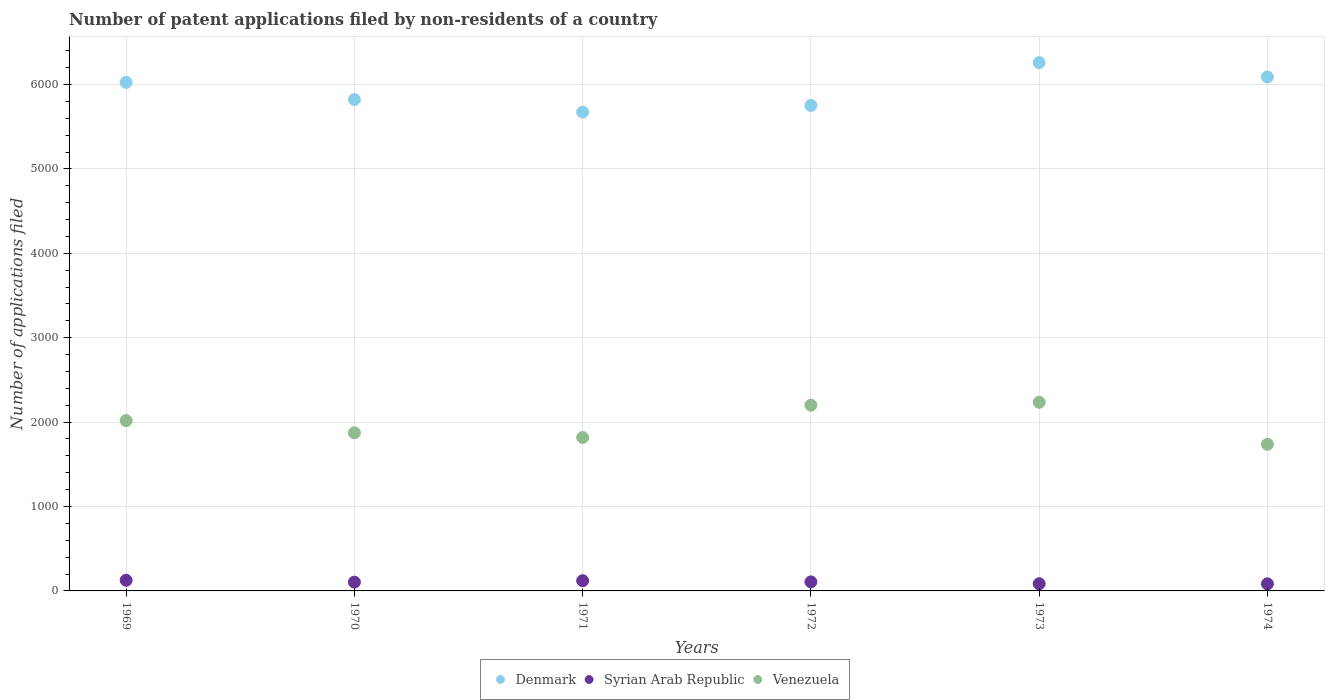How many different coloured dotlines are there?
Make the answer very short. 3. Is the number of dotlines equal to the number of legend labels?
Ensure brevity in your answer.  Yes. What is the number of applications filed in Denmark in 1973?
Your answer should be compact. 6259. Across all years, what is the maximum number of applications filed in Denmark?
Your answer should be compact. 6259. Across all years, what is the minimum number of applications filed in Syrian Arab Republic?
Provide a short and direct response. 84. In which year was the number of applications filed in Venezuela minimum?
Offer a terse response. 1974. What is the total number of applications filed in Syrian Arab Republic in the graph?
Your answer should be compact. 627. What is the difference between the number of applications filed in Venezuela in 1970 and that in 1971?
Your response must be concise. 55. What is the difference between the number of applications filed in Denmark in 1973 and the number of applications filed in Syrian Arab Republic in 1972?
Give a very brief answer. 6152. What is the average number of applications filed in Venezuela per year?
Give a very brief answer. 1980.33. In the year 1974, what is the difference between the number of applications filed in Syrian Arab Republic and number of applications filed in Venezuela?
Make the answer very short. -1653. In how many years, is the number of applications filed in Denmark greater than 1600?
Your answer should be compact. 6. What is the ratio of the number of applications filed in Denmark in 1969 to that in 1973?
Offer a terse response. 0.96. Is the number of applications filed in Denmark in 1969 less than that in 1970?
Make the answer very short. No. Is the difference between the number of applications filed in Syrian Arab Republic in 1972 and 1973 greater than the difference between the number of applications filed in Venezuela in 1972 and 1973?
Provide a succinct answer. Yes. What is the difference between the highest and the second highest number of applications filed in Denmark?
Offer a very short reply. 170. What is the difference between the highest and the lowest number of applications filed in Venezuela?
Give a very brief answer. 498. Is the sum of the number of applications filed in Syrian Arab Republic in 1971 and 1972 greater than the maximum number of applications filed in Denmark across all years?
Offer a terse response. No. Is it the case that in every year, the sum of the number of applications filed in Denmark and number of applications filed in Syrian Arab Republic  is greater than the number of applications filed in Venezuela?
Your answer should be compact. Yes. Does the number of applications filed in Denmark monotonically increase over the years?
Make the answer very short. No. Is the number of applications filed in Denmark strictly greater than the number of applications filed in Venezuela over the years?
Ensure brevity in your answer.  Yes. How many legend labels are there?
Keep it short and to the point. 3. What is the title of the graph?
Make the answer very short. Number of patent applications filed by non-residents of a country. What is the label or title of the X-axis?
Ensure brevity in your answer.  Years. What is the label or title of the Y-axis?
Offer a terse response. Number of applications filed. What is the Number of applications filed in Denmark in 1969?
Your response must be concise. 6025. What is the Number of applications filed in Syrian Arab Republic in 1969?
Offer a terse response. 126. What is the Number of applications filed in Venezuela in 1969?
Your response must be concise. 2018. What is the Number of applications filed in Denmark in 1970?
Your answer should be very brief. 5822. What is the Number of applications filed in Syrian Arab Republic in 1970?
Make the answer very short. 104. What is the Number of applications filed in Venezuela in 1970?
Your answer should be compact. 1873. What is the Number of applications filed in Denmark in 1971?
Ensure brevity in your answer.  5673. What is the Number of applications filed of Syrian Arab Republic in 1971?
Offer a very short reply. 121. What is the Number of applications filed of Venezuela in 1971?
Provide a succinct answer. 1818. What is the Number of applications filed of Denmark in 1972?
Keep it short and to the point. 5752. What is the Number of applications filed of Syrian Arab Republic in 1972?
Ensure brevity in your answer.  107. What is the Number of applications filed of Venezuela in 1972?
Your answer should be compact. 2201. What is the Number of applications filed of Denmark in 1973?
Your answer should be very brief. 6259. What is the Number of applications filed of Syrian Arab Republic in 1973?
Provide a succinct answer. 85. What is the Number of applications filed in Venezuela in 1973?
Offer a terse response. 2235. What is the Number of applications filed in Denmark in 1974?
Make the answer very short. 6089. What is the Number of applications filed of Syrian Arab Republic in 1974?
Your answer should be compact. 84. What is the Number of applications filed in Venezuela in 1974?
Offer a terse response. 1737. Across all years, what is the maximum Number of applications filed in Denmark?
Provide a succinct answer. 6259. Across all years, what is the maximum Number of applications filed of Syrian Arab Republic?
Offer a very short reply. 126. Across all years, what is the maximum Number of applications filed in Venezuela?
Offer a terse response. 2235. Across all years, what is the minimum Number of applications filed of Denmark?
Your answer should be compact. 5673. Across all years, what is the minimum Number of applications filed of Venezuela?
Offer a very short reply. 1737. What is the total Number of applications filed of Denmark in the graph?
Ensure brevity in your answer.  3.56e+04. What is the total Number of applications filed in Syrian Arab Republic in the graph?
Your answer should be compact. 627. What is the total Number of applications filed of Venezuela in the graph?
Give a very brief answer. 1.19e+04. What is the difference between the Number of applications filed of Denmark in 1969 and that in 1970?
Your answer should be compact. 203. What is the difference between the Number of applications filed of Venezuela in 1969 and that in 1970?
Provide a succinct answer. 145. What is the difference between the Number of applications filed in Denmark in 1969 and that in 1971?
Offer a very short reply. 352. What is the difference between the Number of applications filed in Venezuela in 1969 and that in 1971?
Give a very brief answer. 200. What is the difference between the Number of applications filed in Denmark in 1969 and that in 1972?
Ensure brevity in your answer.  273. What is the difference between the Number of applications filed in Venezuela in 1969 and that in 1972?
Make the answer very short. -183. What is the difference between the Number of applications filed of Denmark in 1969 and that in 1973?
Ensure brevity in your answer.  -234. What is the difference between the Number of applications filed in Venezuela in 1969 and that in 1973?
Provide a succinct answer. -217. What is the difference between the Number of applications filed of Denmark in 1969 and that in 1974?
Your answer should be very brief. -64. What is the difference between the Number of applications filed of Syrian Arab Republic in 1969 and that in 1974?
Keep it short and to the point. 42. What is the difference between the Number of applications filed in Venezuela in 1969 and that in 1974?
Your answer should be very brief. 281. What is the difference between the Number of applications filed of Denmark in 1970 and that in 1971?
Offer a terse response. 149. What is the difference between the Number of applications filed of Syrian Arab Republic in 1970 and that in 1972?
Ensure brevity in your answer.  -3. What is the difference between the Number of applications filed of Venezuela in 1970 and that in 1972?
Offer a terse response. -328. What is the difference between the Number of applications filed in Denmark in 1970 and that in 1973?
Give a very brief answer. -437. What is the difference between the Number of applications filed of Venezuela in 1970 and that in 1973?
Offer a very short reply. -362. What is the difference between the Number of applications filed of Denmark in 1970 and that in 1974?
Provide a short and direct response. -267. What is the difference between the Number of applications filed of Venezuela in 1970 and that in 1974?
Offer a very short reply. 136. What is the difference between the Number of applications filed in Denmark in 1971 and that in 1972?
Provide a short and direct response. -79. What is the difference between the Number of applications filed of Venezuela in 1971 and that in 1972?
Offer a terse response. -383. What is the difference between the Number of applications filed in Denmark in 1971 and that in 1973?
Offer a very short reply. -586. What is the difference between the Number of applications filed of Venezuela in 1971 and that in 1973?
Give a very brief answer. -417. What is the difference between the Number of applications filed in Denmark in 1971 and that in 1974?
Offer a terse response. -416. What is the difference between the Number of applications filed of Syrian Arab Republic in 1971 and that in 1974?
Your answer should be compact. 37. What is the difference between the Number of applications filed of Denmark in 1972 and that in 1973?
Your response must be concise. -507. What is the difference between the Number of applications filed in Venezuela in 1972 and that in 1973?
Make the answer very short. -34. What is the difference between the Number of applications filed in Denmark in 1972 and that in 1974?
Make the answer very short. -337. What is the difference between the Number of applications filed in Syrian Arab Republic in 1972 and that in 1974?
Offer a terse response. 23. What is the difference between the Number of applications filed of Venezuela in 1972 and that in 1974?
Ensure brevity in your answer.  464. What is the difference between the Number of applications filed in Denmark in 1973 and that in 1974?
Your answer should be very brief. 170. What is the difference between the Number of applications filed of Venezuela in 1973 and that in 1974?
Offer a terse response. 498. What is the difference between the Number of applications filed in Denmark in 1969 and the Number of applications filed in Syrian Arab Republic in 1970?
Ensure brevity in your answer.  5921. What is the difference between the Number of applications filed of Denmark in 1969 and the Number of applications filed of Venezuela in 1970?
Your answer should be compact. 4152. What is the difference between the Number of applications filed of Syrian Arab Republic in 1969 and the Number of applications filed of Venezuela in 1970?
Offer a very short reply. -1747. What is the difference between the Number of applications filed in Denmark in 1969 and the Number of applications filed in Syrian Arab Republic in 1971?
Give a very brief answer. 5904. What is the difference between the Number of applications filed in Denmark in 1969 and the Number of applications filed in Venezuela in 1971?
Offer a very short reply. 4207. What is the difference between the Number of applications filed of Syrian Arab Republic in 1969 and the Number of applications filed of Venezuela in 1971?
Offer a terse response. -1692. What is the difference between the Number of applications filed in Denmark in 1969 and the Number of applications filed in Syrian Arab Republic in 1972?
Provide a short and direct response. 5918. What is the difference between the Number of applications filed in Denmark in 1969 and the Number of applications filed in Venezuela in 1972?
Provide a short and direct response. 3824. What is the difference between the Number of applications filed of Syrian Arab Republic in 1969 and the Number of applications filed of Venezuela in 1972?
Your response must be concise. -2075. What is the difference between the Number of applications filed of Denmark in 1969 and the Number of applications filed of Syrian Arab Republic in 1973?
Your response must be concise. 5940. What is the difference between the Number of applications filed in Denmark in 1969 and the Number of applications filed in Venezuela in 1973?
Offer a very short reply. 3790. What is the difference between the Number of applications filed of Syrian Arab Republic in 1969 and the Number of applications filed of Venezuela in 1973?
Offer a terse response. -2109. What is the difference between the Number of applications filed in Denmark in 1969 and the Number of applications filed in Syrian Arab Republic in 1974?
Make the answer very short. 5941. What is the difference between the Number of applications filed of Denmark in 1969 and the Number of applications filed of Venezuela in 1974?
Provide a short and direct response. 4288. What is the difference between the Number of applications filed of Syrian Arab Republic in 1969 and the Number of applications filed of Venezuela in 1974?
Make the answer very short. -1611. What is the difference between the Number of applications filed in Denmark in 1970 and the Number of applications filed in Syrian Arab Republic in 1971?
Offer a terse response. 5701. What is the difference between the Number of applications filed of Denmark in 1970 and the Number of applications filed of Venezuela in 1971?
Give a very brief answer. 4004. What is the difference between the Number of applications filed of Syrian Arab Republic in 1970 and the Number of applications filed of Venezuela in 1971?
Give a very brief answer. -1714. What is the difference between the Number of applications filed in Denmark in 1970 and the Number of applications filed in Syrian Arab Republic in 1972?
Give a very brief answer. 5715. What is the difference between the Number of applications filed in Denmark in 1970 and the Number of applications filed in Venezuela in 1972?
Provide a short and direct response. 3621. What is the difference between the Number of applications filed in Syrian Arab Republic in 1970 and the Number of applications filed in Venezuela in 1972?
Provide a succinct answer. -2097. What is the difference between the Number of applications filed of Denmark in 1970 and the Number of applications filed of Syrian Arab Republic in 1973?
Offer a terse response. 5737. What is the difference between the Number of applications filed in Denmark in 1970 and the Number of applications filed in Venezuela in 1973?
Your answer should be very brief. 3587. What is the difference between the Number of applications filed of Syrian Arab Republic in 1970 and the Number of applications filed of Venezuela in 1973?
Make the answer very short. -2131. What is the difference between the Number of applications filed in Denmark in 1970 and the Number of applications filed in Syrian Arab Republic in 1974?
Provide a succinct answer. 5738. What is the difference between the Number of applications filed in Denmark in 1970 and the Number of applications filed in Venezuela in 1974?
Your answer should be compact. 4085. What is the difference between the Number of applications filed in Syrian Arab Republic in 1970 and the Number of applications filed in Venezuela in 1974?
Make the answer very short. -1633. What is the difference between the Number of applications filed in Denmark in 1971 and the Number of applications filed in Syrian Arab Republic in 1972?
Ensure brevity in your answer.  5566. What is the difference between the Number of applications filed of Denmark in 1971 and the Number of applications filed of Venezuela in 1972?
Offer a very short reply. 3472. What is the difference between the Number of applications filed in Syrian Arab Republic in 1971 and the Number of applications filed in Venezuela in 1972?
Provide a succinct answer. -2080. What is the difference between the Number of applications filed in Denmark in 1971 and the Number of applications filed in Syrian Arab Republic in 1973?
Your response must be concise. 5588. What is the difference between the Number of applications filed of Denmark in 1971 and the Number of applications filed of Venezuela in 1973?
Your answer should be very brief. 3438. What is the difference between the Number of applications filed of Syrian Arab Republic in 1971 and the Number of applications filed of Venezuela in 1973?
Ensure brevity in your answer.  -2114. What is the difference between the Number of applications filed in Denmark in 1971 and the Number of applications filed in Syrian Arab Republic in 1974?
Provide a succinct answer. 5589. What is the difference between the Number of applications filed of Denmark in 1971 and the Number of applications filed of Venezuela in 1974?
Offer a very short reply. 3936. What is the difference between the Number of applications filed of Syrian Arab Republic in 1971 and the Number of applications filed of Venezuela in 1974?
Keep it short and to the point. -1616. What is the difference between the Number of applications filed in Denmark in 1972 and the Number of applications filed in Syrian Arab Republic in 1973?
Offer a very short reply. 5667. What is the difference between the Number of applications filed of Denmark in 1972 and the Number of applications filed of Venezuela in 1973?
Provide a succinct answer. 3517. What is the difference between the Number of applications filed of Syrian Arab Republic in 1972 and the Number of applications filed of Venezuela in 1973?
Ensure brevity in your answer.  -2128. What is the difference between the Number of applications filed of Denmark in 1972 and the Number of applications filed of Syrian Arab Republic in 1974?
Provide a succinct answer. 5668. What is the difference between the Number of applications filed in Denmark in 1972 and the Number of applications filed in Venezuela in 1974?
Ensure brevity in your answer.  4015. What is the difference between the Number of applications filed of Syrian Arab Republic in 1972 and the Number of applications filed of Venezuela in 1974?
Give a very brief answer. -1630. What is the difference between the Number of applications filed of Denmark in 1973 and the Number of applications filed of Syrian Arab Republic in 1974?
Provide a short and direct response. 6175. What is the difference between the Number of applications filed of Denmark in 1973 and the Number of applications filed of Venezuela in 1974?
Make the answer very short. 4522. What is the difference between the Number of applications filed of Syrian Arab Republic in 1973 and the Number of applications filed of Venezuela in 1974?
Provide a short and direct response. -1652. What is the average Number of applications filed of Denmark per year?
Keep it short and to the point. 5936.67. What is the average Number of applications filed in Syrian Arab Republic per year?
Make the answer very short. 104.5. What is the average Number of applications filed in Venezuela per year?
Provide a short and direct response. 1980.33. In the year 1969, what is the difference between the Number of applications filed of Denmark and Number of applications filed of Syrian Arab Republic?
Offer a terse response. 5899. In the year 1969, what is the difference between the Number of applications filed in Denmark and Number of applications filed in Venezuela?
Give a very brief answer. 4007. In the year 1969, what is the difference between the Number of applications filed in Syrian Arab Republic and Number of applications filed in Venezuela?
Offer a terse response. -1892. In the year 1970, what is the difference between the Number of applications filed in Denmark and Number of applications filed in Syrian Arab Republic?
Give a very brief answer. 5718. In the year 1970, what is the difference between the Number of applications filed of Denmark and Number of applications filed of Venezuela?
Your response must be concise. 3949. In the year 1970, what is the difference between the Number of applications filed of Syrian Arab Republic and Number of applications filed of Venezuela?
Make the answer very short. -1769. In the year 1971, what is the difference between the Number of applications filed in Denmark and Number of applications filed in Syrian Arab Republic?
Keep it short and to the point. 5552. In the year 1971, what is the difference between the Number of applications filed in Denmark and Number of applications filed in Venezuela?
Keep it short and to the point. 3855. In the year 1971, what is the difference between the Number of applications filed in Syrian Arab Republic and Number of applications filed in Venezuela?
Ensure brevity in your answer.  -1697. In the year 1972, what is the difference between the Number of applications filed in Denmark and Number of applications filed in Syrian Arab Republic?
Make the answer very short. 5645. In the year 1972, what is the difference between the Number of applications filed in Denmark and Number of applications filed in Venezuela?
Provide a short and direct response. 3551. In the year 1972, what is the difference between the Number of applications filed of Syrian Arab Republic and Number of applications filed of Venezuela?
Your response must be concise. -2094. In the year 1973, what is the difference between the Number of applications filed of Denmark and Number of applications filed of Syrian Arab Republic?
Provide a succinct answer. 6174. In the year 1973, what is the difference between the Number of applications filed in Denmark and Number of applications filed in Venezuela?
Keep it short and to the point. 4024. In the year 1973, what is the difference between the Number of applications filed of Syrian Arab Republic and Number of applications filed of Venezuela?
Your answer should be compact. -2150. In the year 1974, what is the difference between the Number of applications filed of Denmark and Number of applications filed of Syrian Arab Republic?
Offer a terse response. 6005. In the year 1974, what is the difference between the Number of applications filed in Denmark and Number of applications filed in Venezuela?
Provide a short and direct response. 4352. In the year 1974, what is the difference between the Number of applications filed in Syrian Arab Republic and Number of applications filed in Venezuela?
Your response must be concise. -1653. What is the ratio of the Number of applications filed of Denmark in 1969 to that in 1970?
Keep it short and to the point. 1.03. What is the ratio of the Number of applications filed in Syrian Arab Republic in 1969 to that in 1970?
Offer a terse response. 1.21. What is the ratio of the Number of applications filed of Venezuela in 1969 to that in 1970?
Your answer should be compact. 1.08. What is the ratio of the Number of applications filed in Denmark in 1969 to that in 1971?
Your response must be concise. 1.06. What is the ratio of the Number of applications filed of Syrian Arab Republic in 1969 to that in 1971?
Provide a short and direct response. 1.04. What is the ratio of the Number of applications filed of Venezuela in 1969 to that in 1971?
Your response must be concise. 1.11. What is the ratio of the Number of applications filed of Denmark in 1969 to that in 1972?
Offer a terse response. 1.05. What is the ratio of the Number of applications filed in Syrian Arab Republic in 1969 to that in 1972?
Provide a succinct answer. 1.18. What is the ratio of the Number of applications filed of Venezuela in 1969 to that in 1972?
Give a very brief answer. 0.92. What is the ratio of the Number of applications filed in Denmark in 1969 to that in 1973?
Your answer should be compact. 0.96. What is the ratio of the Number of applications filed of Syrian Arab Republic in 1969 to that in 1973?
Your response must be concise. 1.48. What is the ratio of the Number of applications filed in Venezuela in 1969 to that in 1973?
Your answer should be very brief. 0.9. What is the ratio of the Number of applications filed in Syrian Arab Republic in 1969 to that in 1974?
Provide a succinct answer. 1.5. What is the ratio of the Number of applications filed of Venezuela in 1969 to that in 1974?
Provide a succinct answer. 1.16. What is the ratio of the Number of applications filed in Denmark in 1970 to that in 1971?
Provide a short and direct response. 1.03. What is the ratio of the Number of applications filed of Syrian Arab Republic in 1970 to that in 1971?
Keep it short and to the point. 0.86. What is the ratio of the Number of applications filed in Venezuela in 1970 to that in 1971?
Give a very brief answer. 1.03. What is the ratio of the Number of applications filed in Denmark in 1970 to that in 1972?
Your answer should be compact. 1.01. What is the ratio of the Number of applications filed of Syrian Arab Republic in 1970 to that in 1972?
Offer a very short reply. 0.97. What is the ratio of the Number of applications filed in Venezuela in 1970 to that in 1972?
Give a very brief answer. 0.85. What is the ratio of the Number of applications filed in Denmark in 1970 to that in 1973?
Keep it short and to the point. 0.93. What is the ratio of the Number of applications filed of Syrian Arab Republic in 1970 to that in 1973?
Your answer should be compact. 1.22. What is the ratio of the Number of applications filed in Venezuela in 1970 to that in 1973?
Provide a short and direct response. 0.84. What is the ratio of the Number of applications filed in Denmark in 1970 to that in 1974?
Offer a terse response. 0.96. What is the ratio of the Number of applications filed in Syrian Arab Republic in 1970 to that in 1974?
Make the answer very short. 1.24. What is the ratio of the Number of applications filed of Venezuela in 1970 to that in 1974?
Offer a terse response. 1.08. What is the ratio of the Number of applications filed in Denmark in 1971 to that in 1972?
Offer a very short reply. 0.99. What is the ratio of the Number of applications filed of Syrian Arab Republic in 1971 to that in 1972?
Your answer should be compact. 1.13. What is the ratio of the Number of applications filed of Venezuela in 1971 to that in 1972?
Your answer should be compact. 0.83. What is the ratio of the Number of applications filed in Denmark in 1971 to that in 1973?
Give a very brief answer. 0.91. What is the ratio of the Number of applications filed in Syrian Arab Republic in 1971 to that in 1973?
Your answer should be very brief. 1.42. What is the ratio of the Number of applications filed in Venezuela in 1971 to that in 1973?
Your response must be concise. 0.81. What is the ratio of the Number of applications filed of Denmark in 1971 to that in 1974?
Ensure brevity in your answer.  0.93. What is the ratio of the Number of applications filed of Syrian Arab Republic in 1971 to that in 1974?
Give a very brief answer. 1.44. What is the ratio of the Number of applications filed in Venezuela in 1971 to that in 1974?
Your answer should be very brief. 1.05. What is the ratio of the Number of applications filed in Denmark in 1972 to that in 1973?
Provide a short and direct response. 0.92. What is the ratio of the Number of applications filed of Syrian Arab Republic in 1972 to that in 1973?
Make the answer very short. 1.26. What is the ratio of the Number of applications filed of Denmark in 1972 to that in 1974?
Ensure brevity in your answer.  0.94. What is the ratio of the Number of applications filed of Syrian Arab Republic in 1972 to that in 1974?
Your answer should be compact. 1.27. What is the ratio of the Number of applications filed of Venezuela in 1972 to that in 1974?
Provide a short and direct response. 1.27. What is the ratio of the Number of applications filed of Denmark in 1973 to that in 1974?
Make the answer very short. 1.03. What is the ratio of the Number of applications filed in Syrian Arab Republic in 1973 to that in 1974?
Make the answer very short. 1.01. What is the ratio of the Number of applications filed of Venezuela in 1973 to that in 1974?
Give a very brief answer. 1.29. What is the difference between the highest and the second highest Number of applications filed in Denmark?
Provide a succinct answer. 170. What is the difference between the highest and the lowest Number of applications filed of Denmark?
Make the answer very short. 586. What is the difference between the highest and the lowest Number of applications filed of Syrian Arab Republic?
Ensure brevity in your answer.  42. What is the difference between the highest and the lowest Number of applications filed in Venezuela?
Your answer should be very brief. 498. 